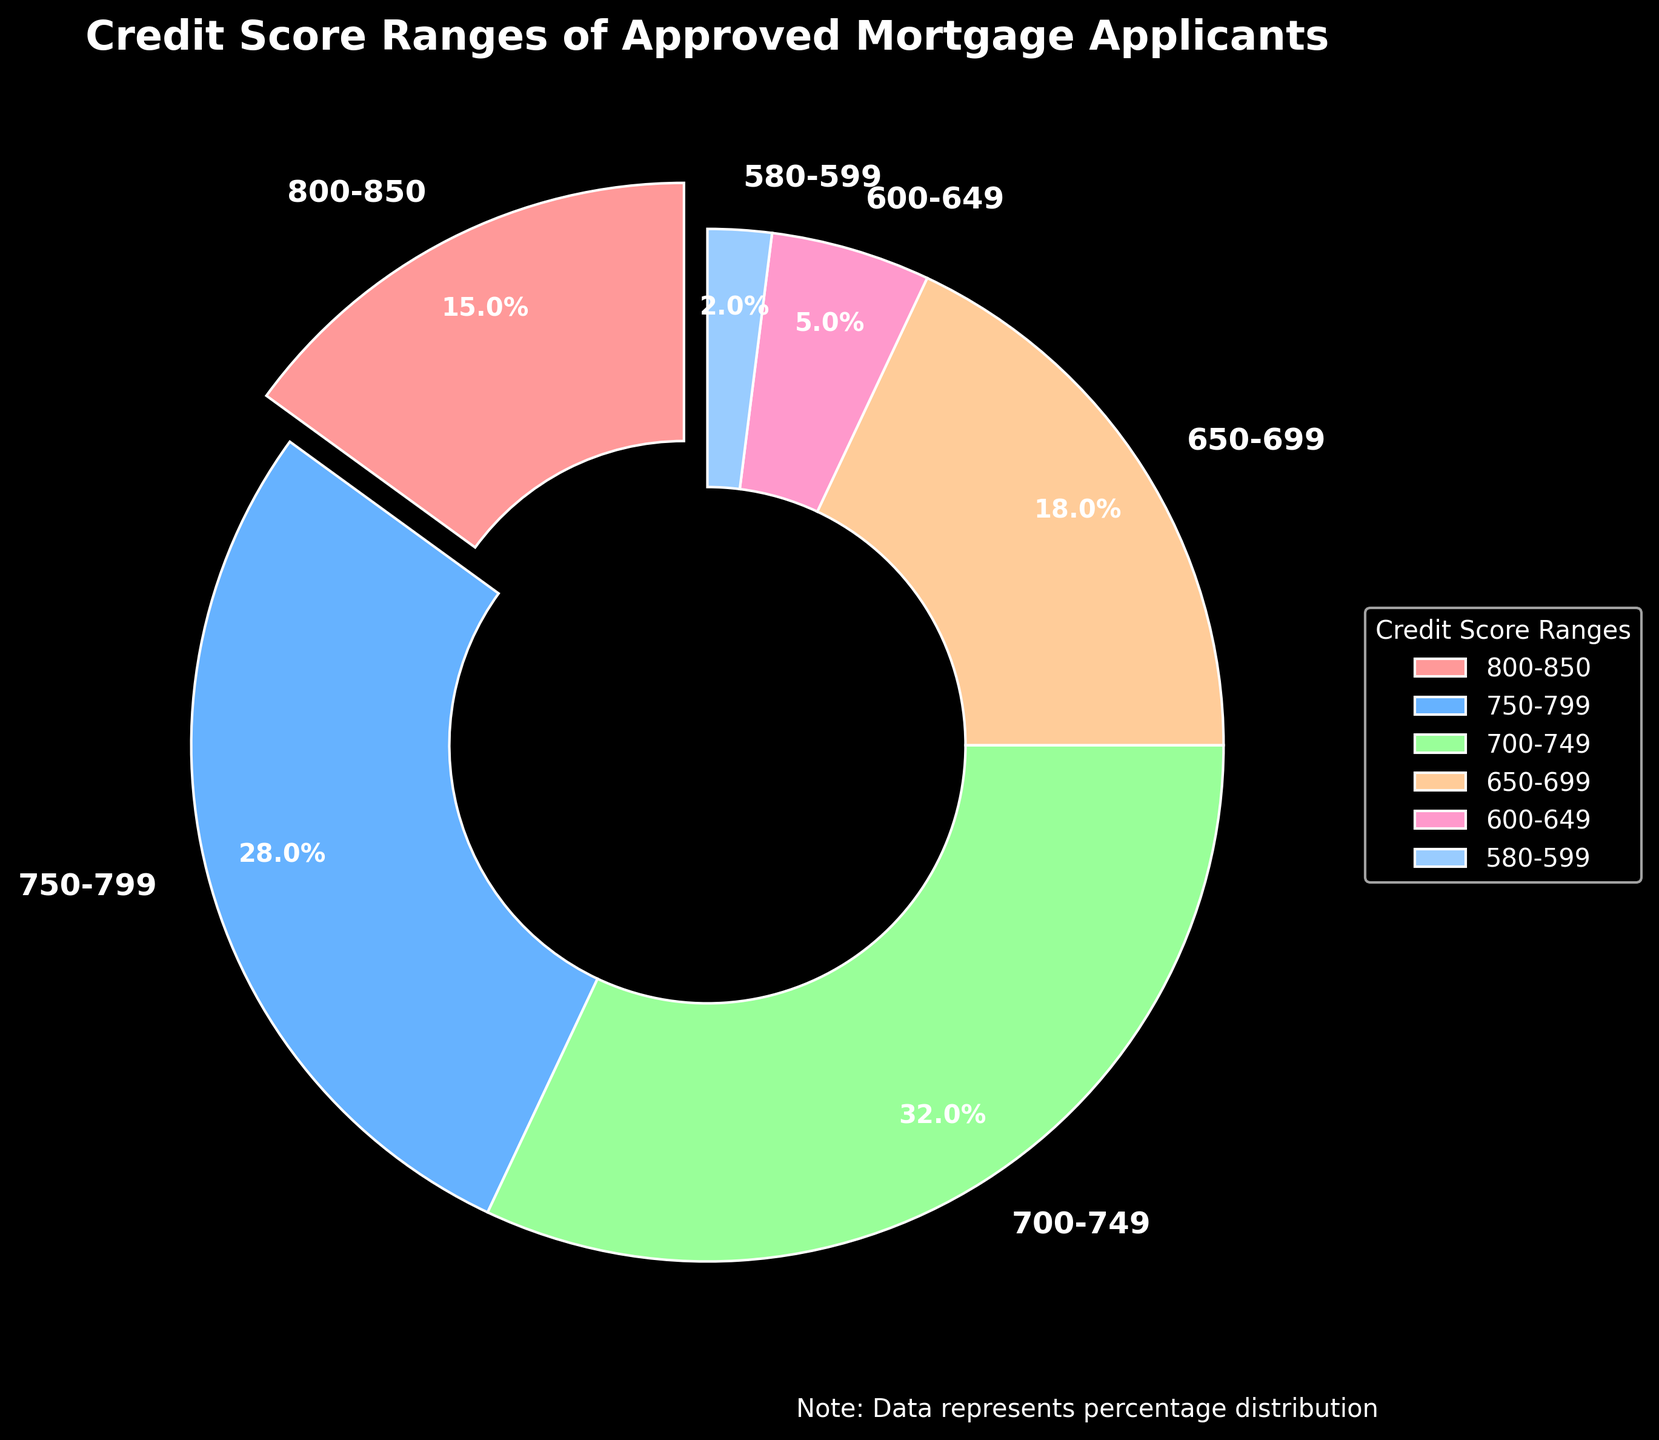What percentage of approved applicants have a credit score below 650? To find the percentage of applicants with a credit score below 650, add the percentages of the 600-649 and 580-599 ranges: 5% + 2%.
Answer: 7% Which credit score range has the largest proportion of approved mortgage applicants? The 700-749 range has the largest slice of the pie chart, representing 32%.
Answer: 700-749 How many credit score ranges have smaller proportions than the 650-699 range? To determine this, count the slices with a smaller percentage than the 18% of the 650-699 range: the 600-649 range (5%) and the 580-599 range (2%).
Answer: 2 Does the sum of percentages for the top two credit score ranges exceed 50%? The top two ranges are 700-749 (32%) and 750-799 (28%). Adding these: 32% + 28% = 60%, which exceeds 50%.
Answer: Yes What is the difference in percentage between the 750-799 and 650-699 credit score ranges? Subtract the percentage of the 650-699 range from the 750-799 range: 28% - 18%.
Answer: 10% What is the most common color representing the top two credit score ranges? The colors representing the 700-749 and 750-799 ranges are green and blue, respectively. Blue appears more frequently in the slices for the top two ranges.
Answer: Blue Compare the proportions of applicants in the 800-850 and 750-799 ranges. Which is larger? Compare 15% for the 800-850 range and 28% for the 750-799 range. The 750-799 range is larger.
Answer: 750-799 Are there any credit score ranges with equal proportions? Each slice represents a different proportion. No credit score ranges have equal proportions.
Answer: No How does the proportion of the 600-649 range compare to the sum of the 580-599 and 750-799 ranges? Add the 580-599 and 750-799 percentages: 2% + 28% = 30%. The 600-649 percentage is 5%, which is smaller.
Answer: Smaller 